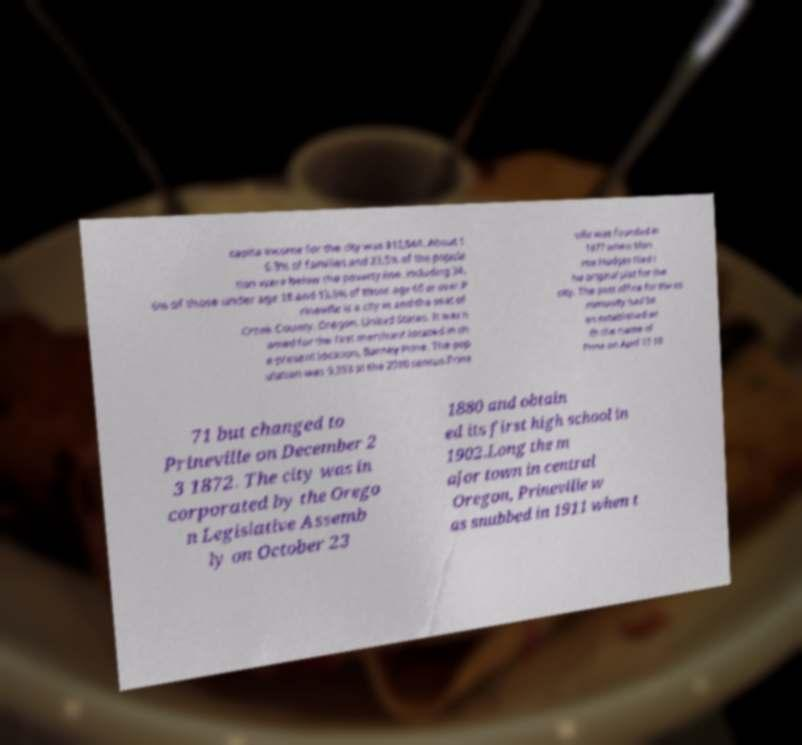There's text embedded in this image that I need extracted. Can you transcribe it verbatim? capita income for the city was $12,544. About 1 6.3% of families and 23.5% of the popula tion were below the poverty line, including 34. 6% of those under age 18 and 13.6% of those age 65 or over.P rineville is a city in and the seat of Crook County, Oregon, United States. It was n amed for the first merchant located in th e present location, Barney Prine. The pop ulation was 9,253 at the 2010 census.Prine ville was founded in 1877 when Mon roe Hodges filed t he original plat for the city. The post office for the co mmunity had be en established wi th the name of Prine on April 13 18 71 but changed to Prineville on December 2 3 1872. The city was in corporated by the Orego n Legislative Assemb ly on October 23 1880 and obtain ed its first high school in 1902.Long the m ajor town in central Oregon, Prineville w as snubbed in 1911 when t 